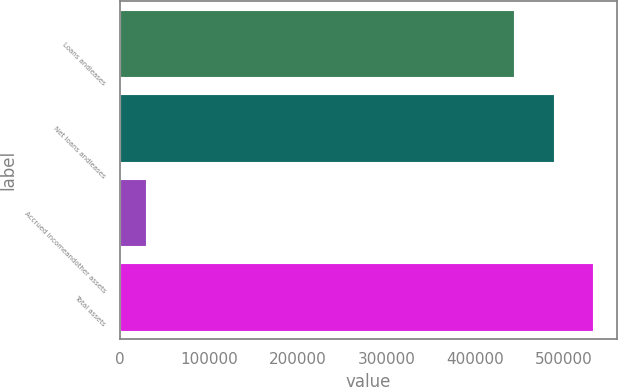Convert chart. <chart><loc_0><loc_0><loc_500><loc_500><bar_chart><fcel>Loans andleases<fcel>Net loans andleases<fcel>Accrued incomeandother assets<fcel>Total assets<nl><fcel>443854<fcel>488239<fcel>29857<fcel>532625<nl></chart> 